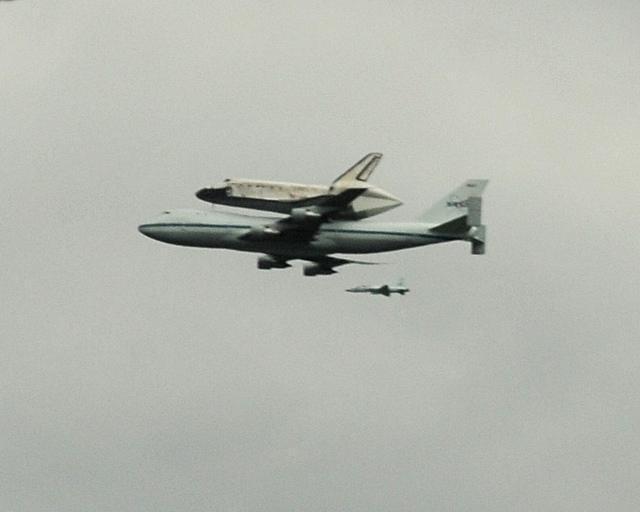How many planes are there?
Give a very brief answer. 2. How many airplanes are there?
Give a very brief answer. 2. How many people are in the water?
Give a very brief answer. 0. 